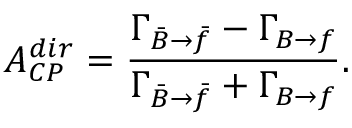Convert formula to latex. <formula><loc_0><loc_0><loc_500><loc_500>A _ { C P } ^ { d i r } = \frac { \Gamma _ { \bar { B } \to \bar { f } } - \Gamma _ { B \to f } } { \Gamma _ { \bar { B } \to \bar { f } } + \Gamma _ { B \to f } } .</formula> 